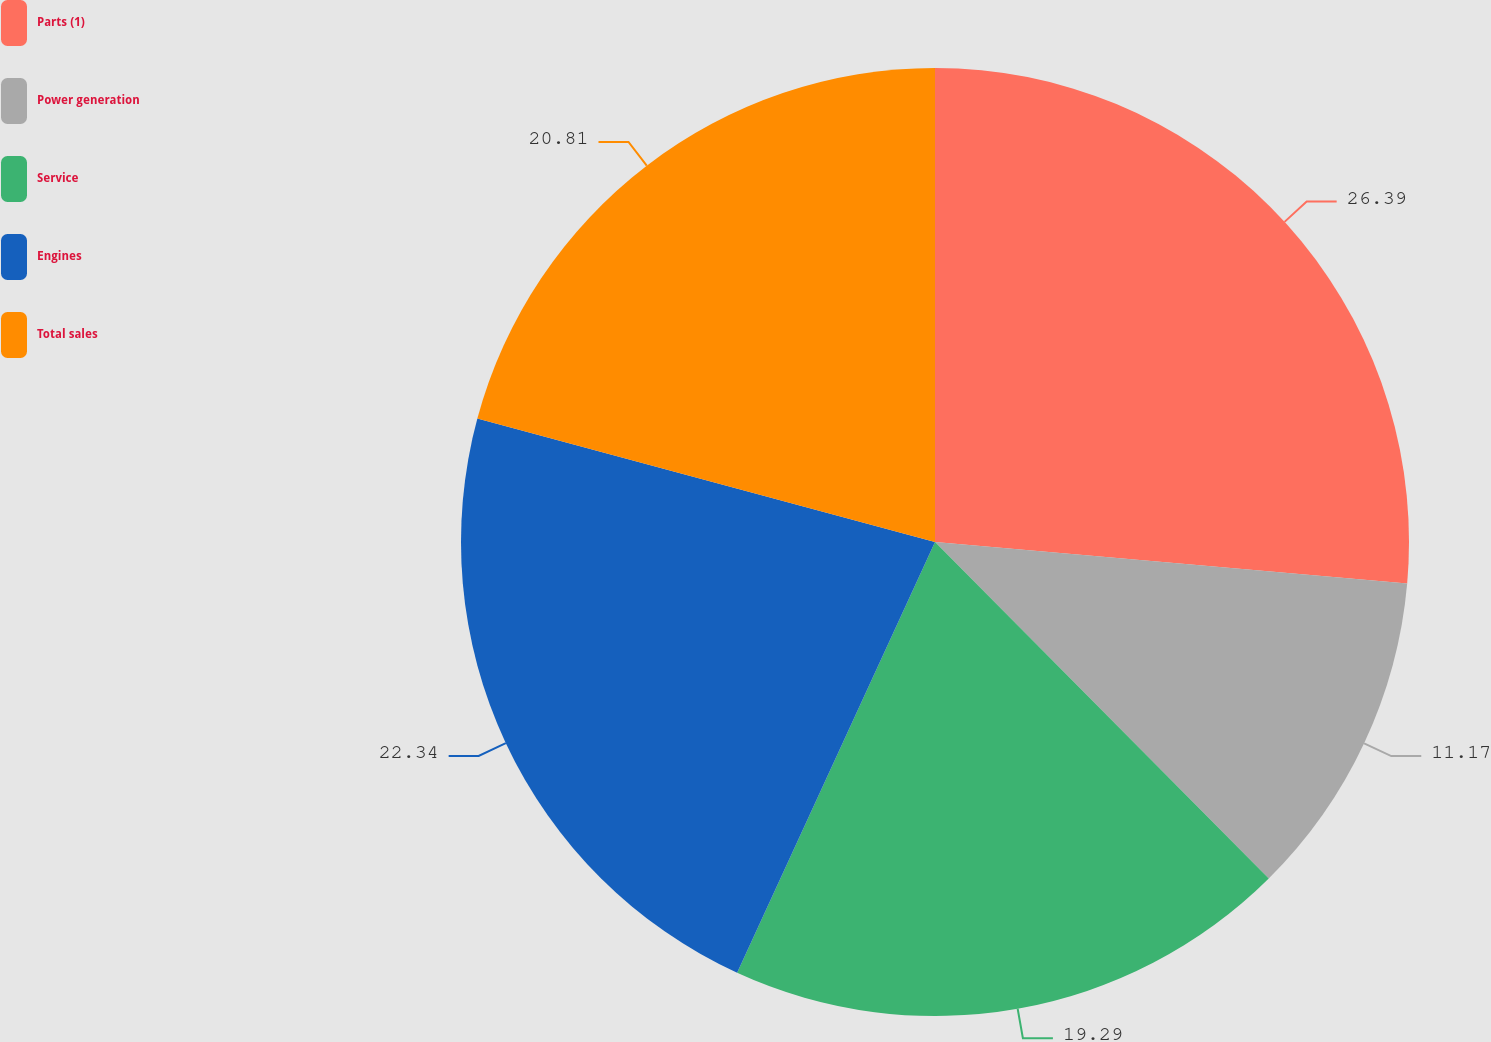Convert chart to OTSL. <chart><loc_0><loc_0><loc_500><loc_500><pie_chart><fcel>Parts (1)<fcel>Power generation<fcel>Service<fcel>Engines<fcel>Total sales<nl><fcel>26.4%<fcel>11.17%<fcel>19.29%<fcel>22.34%<fcel>20.81%<nl></chart> 